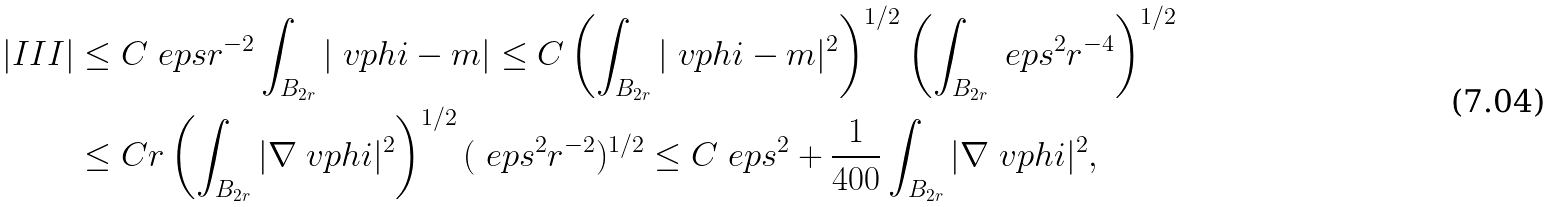Convert formula to latex. <formula><loc_0><loc_0><loc_500><loc_500>| I I I | & \leq C \ e p s r ^ { - 2 } \int _ { B _ { 2 r } } | \ v p h i - m | \leq C \left ( \int _ { B _ { 2 r } } | \ v p h i - m | ^ { 2 } \right ) ^ { 1 / 2 } \left ( \int _ { B _ { 2 r } } \ e p s ^ { 2 } r ^ { - 4 } \right ) ^ { 1 / 2 } \\ & \leq C r \left ( \int _ { B _ { 2 r } } | \nabla \ v p h i | ^ { 2 } \right ) ^ { 1 / 2 } ( \ e p s ^ { 2 } r ^ { - 2 } ) ^ { 1 / 2 } \leq C \ e p s ^ { 2 } + \frac { 1 } { 4 0 0 } \int _ { B _ { 2 r } } | \nabla \ v p h i | ^ { 2 } ,</formula> 